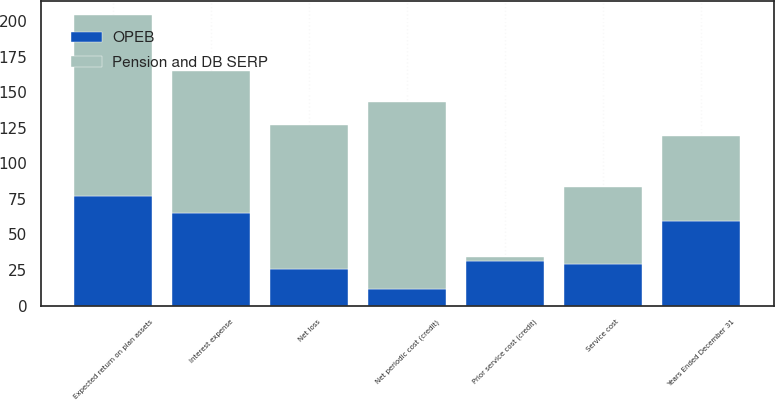Convert chart to OTSL. <chart><loc_0><loc_0><loc_500><loc_500><stacked_bar_chart><ecel><fcel>Years Ended December 31<fcel>Service cost<fcel>Interest expense<fcel>Expected return on plan assets<fcel>Net loss<fcel>Prior service cost (credit)<fcel>Net periodic cost (credit)<nl><fcel>Pension and DB SERP<fcel>59.5<fcel>54<fcel>100<fcel>127<fcel>101<fcel>3<fcel>131<nl><fcel>OPEB<fcel>59.5<fcel>29<fcel>65<fcel>77<fcel>26<fcel>31<fcel>12<nl></chart> 